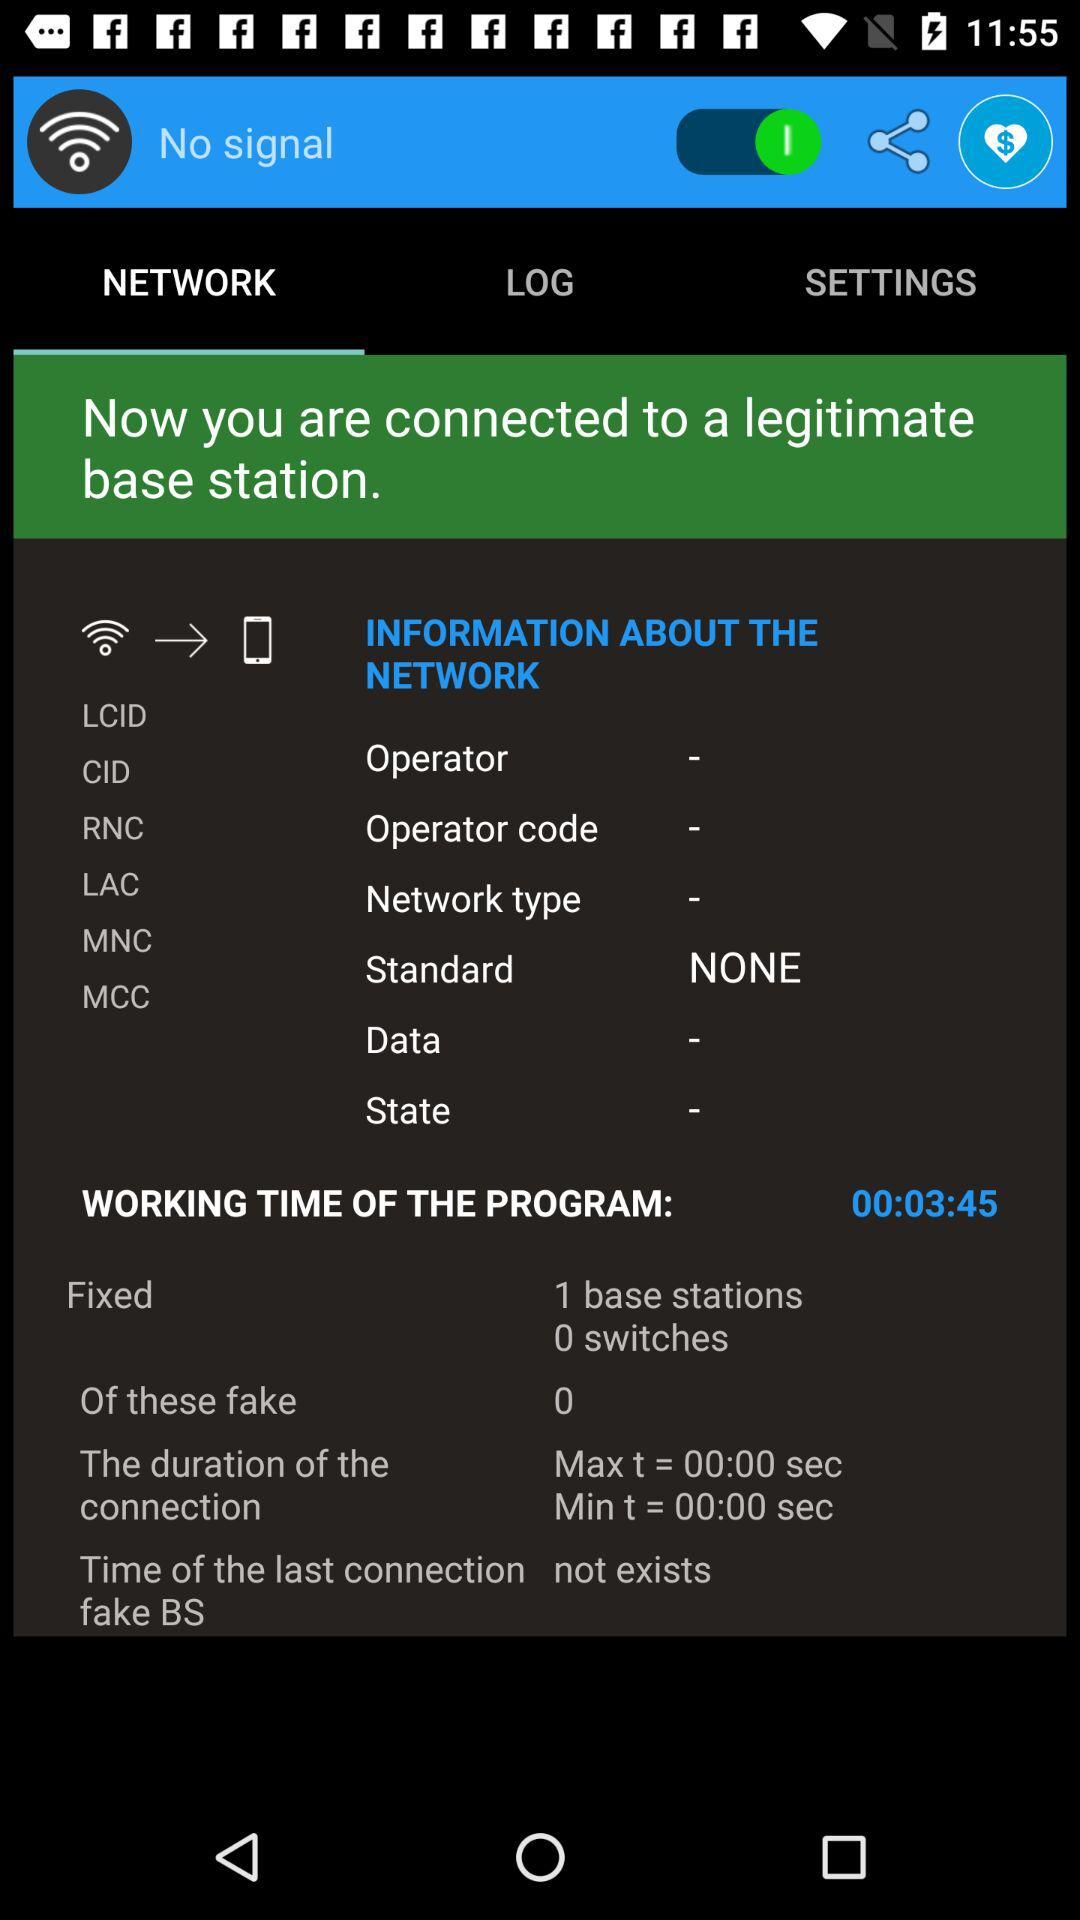What is the minimum duration of the connection? The minimum duration of the connection is 00:00 seconds. 